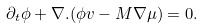Convert formula to latex. <formula><loc_0><loc_0><loc_500><loc_500>\partial _ { t } \phi + \nabla . ( \phi v - M \nabla \mu ) = 0 .</formula> 